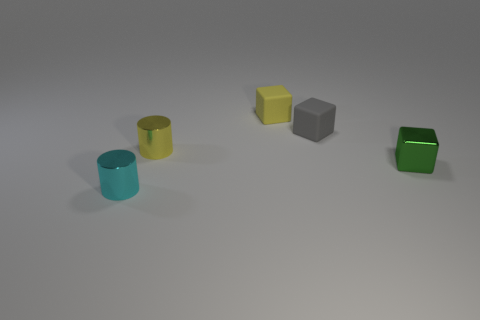What number of tiny objects are cyan cylinders or blocks?
Keep it short and to the point. 4. What is the size of the shiny thing that is on the right side of the small yellow matte thing?
Your answer should be very brief. Small. Is there a tiny metal cylinder of the same color as the metal block?
Make the answer very short. No. There is a tiny matte object that is behind the tiny gray matte thing; what number of small cyan metallic objects are behind it?
Keep it short and to the point. 0. How many other tiny cylinders are made of the same material as the small cyan cylinder?
Make the answer very short. 1. There is a tiny green shiny object; are there any tiny gray cubes left of it?
Make the answer very short. Yes. There is another rubber thing that is the same size as the gray thing; what color is it?
Offer a terse response. Yellow. What number of objects are either tiny cylinders behind the tiny green cube or red things?
Your answer should be compact. 1. What size is the metallic object that is both behind the cyan metallic thing and on the left side of the green metallic object?
Your answer should be very brief. Small. What number of other things are the same size as the gray rubber object?
Make the answer very short. 4. 